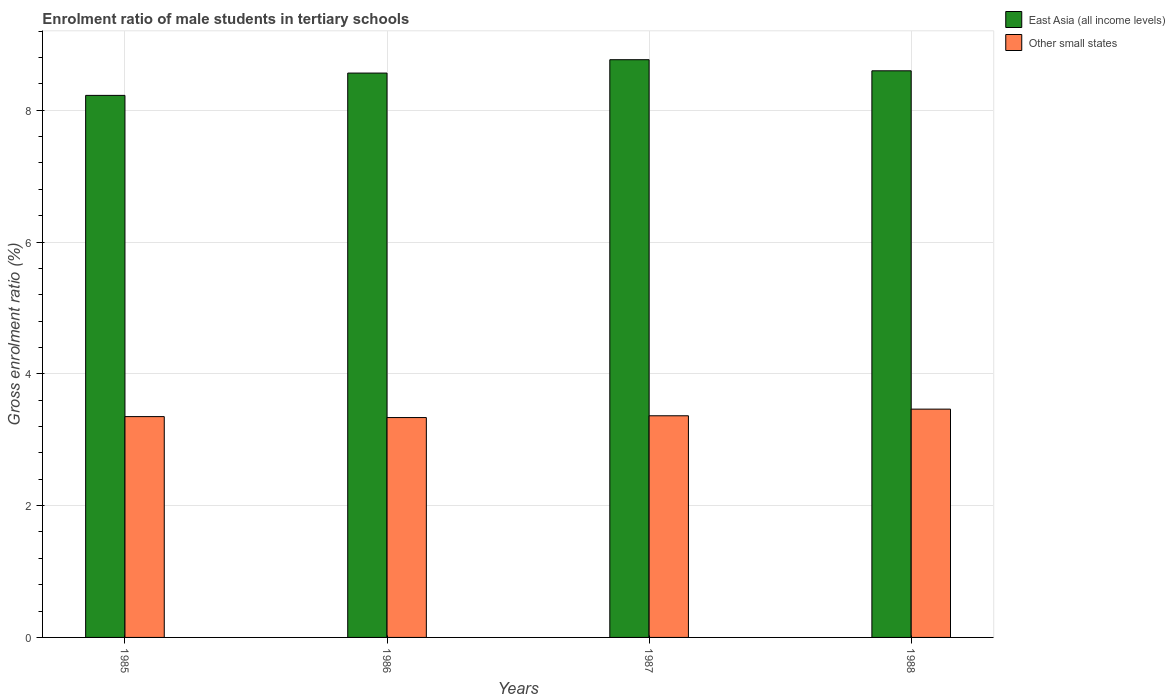How many different coloured bars are there?
Give a very brief answer. 2. How many bars are there on the 3rd tick from the right?
Keep it short and to the point. 2. What is the label of the 1st group of bars from the left?
Provide a short and direct response. 1985. In how many cases, is the number of bars for a given year not equal to the number of legend labels?
Ensure brevity in your answer.  0. What is the enrolment ratio of male students in tertiary schools in Other small states in 1987?
Your answer should be compact. 3.36. Across all years, what is the maximum enrolment ratio of male students in tertiary schools in East Asia (all income levels)?
Ensure brevity in your answer.  8.77. Across all years, what is the minimum enrolment ratio of male students in tertiary schools in East Asia (all income levels)?
Make the answer very short. 8.23. In which year was the enrolment ratio of male students in tertiary schools in East Asia (all income levels) minimum?
Provide a short and direct response. 1985. What is the total enrolment ratio of male students in tertiary schools in Other small states in the graph?
Make the answer very short. 13.52. What is the difference between the enrolment ratio of male students in tertiary schools in East Asia (all income levels) in 1986 and that in 1987?
Provide a short and direct response. -0.2. What is the difference between the enrolment ratio of male students in tertiary schools in East Asia (all income levels) in 1986 and the enrolment ratio of male students in tertiary schools in Other small states in 1985?
Your answer should be compact. 5.21. What is the average enrolment ratio of male students in tertiary schools in East Asia (all income levels) per year?
Your answer should be very brief. 8.54. In the year 1986, what is the difference between the enrolment ratio of male students in tertiary schools in Other small states and enrolment ratio of male students in tertiary schools in East Asia (all income levels)?
Your answer should be compact. -5.23. In how many years, is the enrolment ratio of male students in tertiary schools in Other small states greater than 3.2 %?
Make the answer very short. 4. What is the ratio of the enrolment ratio of male students in tertiary schools in Other small states in 1985 to that in 1988?
Offer a very short reply. 0.97. Is the enrolment ratio of male students in tertiary schools in East Asia (all income levels) in 1987 less than that in 1988?
Keep it short and to the point. No. What is the difference between the highest and the second highest enrolment ratio of male students in tertiary schools in East Asia (all income levels)?
Your response must be concise. 0.17. What is the difference between the highest and the lowest enrolment ratio of male students in tertiary schools in Other small states?
Provide a short and direct response. 0.13. In how many years, is the enrolment ratio of male students in tertiary schools in Other small states greater than the average enrolment ratio of male students in tertiary schools in Other small states taken over all years?
Keep it short and to the point. 1. Is the sum of the enrolment ratio of male students in tertiary schools in East Asia (all income levels) in 1986 and 1988 greater than the maximum enrolment ratio of male students in tertiary schools in Other small states across all years?
Make the answer very short. Yes. What does the 1st bar from the left in 1988 represents?
Ensure brevity in your answer.  East Asia (all income levels). What does the 2nd bar from the right in 1985 represents?
Keep it short and to the point. East Asia (all income levels). How many bars are there?
Your response must be concise. 8. Are all the bars in the graph horizontal?
Ensure brevity in your answer.  No. What is the difference between two consecutive major ticks on the Y-axis?
Provide a short and direct response. 2. Where does the legend appear in the graph?
Offer a terse response. Top right. How many legend labels are there?
Make the answer very short. 2. How are the legend labels stacked?
Offer a very short reply. Vertical. What is the title of the graph?
Offer a terse response. Enrolment ratio of male students in tertiary schools. Does "Fiji" appear as one of the legend labels in the graph?
Provide a succinct answer. No. What is the label or title of the X-axis?
Your answer should be very brief. Years. What is the Gross enrolment ratio (%) of East Asia (all income levels) in 1985?
Ensure brevity in your answer.  8.23. What is the Gross enrolment ratio (%) of Other small states in 1985?
Ensure brevity in your answer.  3.35. What is the Gross enrolment ratio (%) in East Asia (all income levels) in 1986?
Keep it short and to the point. 8.56. What is the Gross enrolment ratio (%) in Other small states in 1986?
Ensure brevity in your answer.  3.34. What is the Gross enrolment ratio (%) in East Asia (all income levels) in 1987?
Offer a terse response. 8.77. What is the Gross enrolment ratio (%) of Other small states in 1987?
Give a very brief answer. 3.36. What is the Gross enrolment ratio (%) of East Asia (all income levels) in 1988?
Offer a very short reply. 8.6. What is the Gross enrolment ratio (%) of Other small states in 1988?
Make the answer very short. 3.46. Across all years, what is the maximum Gross enrolment ratio (%) in East Asia (all income levels)?
Provide a succinct answer. 8.77. Across all years, what is the maximum Gross enrolment ratio (%) in Other small states?
Your response must be concise. 3.46. Across all years, what is the minimum Gross enrolment ratio (%) in East Asia (all income levels)?
Make the answer very short. 8.23. Across all years, what is the minimum Gross enrolment ratio (%) of Other small states?
Give a very brief answer. 3.34. What is the total Gross enrolment ratio (%) in East Asia (all income levels) in the graph?
Your response must be concise. 34.15. What is the total Gross enrolment ratio (%) of Other small states in the graph?
Provide a succinct answer. 13.52. What is the difference between the Gross enrolment ratio (%) of East Asia (all income levels) in 1985 and that in 1986?
Provide a succinct answer. -0.34. What is the difference between the Gross enrolment ratio (%) of Other small states in 1985 and that in 1986?
Give a very brief answer. 0.01. What is the difference between the Gross enrolment ratio (%) of East Asia (all income levels) in 1985 and that in 1987?
Provide a short and direct response. -0.54. What is the difference between the Gross enrolment ratio (%) in Other small states in 1985 and that in 1987?
Keep it short and to the point. -0.01. What is the difference between the Gross enrolment ratio (%) in East Asia (all income levels) in 1985 and that in 1988?
Provide a short and direct response. -0.37. What is the difference between the Gross enrolment ratio (%) of Other small states in 1985 and that in 1988?
Ensure brevity in your answer.  -0.11. What is the difference between the Gross enrolment ratio (%) in East Asia (all income levels) in 1986 and that in 1987?
Provide a succinct answer. -0.2. What is the difference between the Gross enrolment ratio (%) in Other small states in 1986 and that in 1987?
Provide a short and direct response. -0.03. What is the difference between the Gross enrolment ratio (%) in East Asia (all income levels) in 1986 and that in 1988?
Your answer should be very brief. -0.03. What is the difference between the Gross enrolment ratio (%) in Other small states in 1986 and that in 1988?
Offer a terse response. -0.13. What is the difference between the Gross enrolment ratio (%) in East Asia (all income levels) in 1987 and that in 1988?
Your answer should be compact. 0.17. What is the difference between the Gross enrolment ratio (%) in Other small states in 1987 and that in 1988?
Keep it short and to the point. -0.1. What is the difference between the Gross enrolment ratio (%) in East Asia (all income levels) in 1985 and the Gross enrolment ratio (%) in Other small states in 1986?
Offer a terse response. 4.89. What is the difference between the Gross enrolment ratio (%) of East Asia (all income levels) in 1985 and the Gross enrolment ratio (%) of Other small states in 1987?
Your response must be concise. 4.86. What is the difference between the Gross enrolment ratio (%) in East Asia (all income levels) in 1985 and the Gross enrolment ratio (%) in Other small states in 1988?
Offer a terse response. 4.76. What is the difference between the Gross enrolment ratio (%) of East Asia (all income levels) in 1986 and the Gross enrolment ratio (%) of Other small states in 1987?
Keep it short and to the point. 5.2. What is the difference between the Gross enrolment ratio (%) of East Asia (all income levels) in 1986 and the Gross enrolment ratio (%) of Other small states in 1988?
Give a very brief answer. 5.1. What is the difference between the Gross enrolment ratio (%) in East Asia (all income levels) in 1987 and the Gross enrolment ratio (%) in Other small states in 1988?
Provide a succinct answer. 5.3. What is the average Gross enrolment ratio (%) of East Asia (all income levels) per year?
Offer a terse response. 8.54. What is the average Gross enrolment ratio (%) of Other small states per year?
Give a very brief answer. 3.38. In the year 1985, what is the difference between the Gross enrolment ratio (%) of East Asia (all income levels) and Gross enrolment ratio (%) of Other small states?
Your answer should be very brief. 4.87. In the year 1986, what is the difference between the Gross enrolment ratio (%) of East Asia (all income levels) and Gross enrolment ratio (%) of Other small states?
Your response must be concise. 5.23. In the year 1987, what is the difference between the Gross enrolment ratio (%) in East Asia (all income levels) and Gross enrolment ratio (%) in Other small states?
Offer a terse response. 5.4. In the year 1988, what is the difference between the Gross enrolment ratio (%) of East Asia (all income levels) and Gross enrolment ratio (%) of Other small states?
Provide a short and direct response. 5.13. What is the ratio of the Gross enrolment ratio (%) of East Asia (all income levels) in 1985 to that in 1986?
Your answer should be compact. 0.96. What is the ratio of the Gross enrolment ratio (%) of East Asia (all income levels) in 1985 to that in 1987?
Give a very brief answer. 0.94. What is the ratio of the Gross enrolment ratio (%) in East Asia (all income levels) in 1985 to that in 1988?
Your answer should be compact. 0.96. What is the ratio of the Gross enrolment ratio (%) in Other small states in 1985 to that in 1988?
Provide a short and direct response. 0.97. What is the ratio of the Gross enrolment ratio (%) of East Asia (all income levels) in 1986 to that in 1987?
Make the answer very short. 0.98. What is the ratio of the Gross enrolment ratio (%) of Other small states in 1986 to that in 1987?
Your answer should be compact. 0.99. What is the ratio of the Gross enrolment ratio (%) in Other small states in 1986 to that in 1988?
Offer a very short reply. 0.96. What is the ratio of the Gross enrolment ratio (%) of East Asia (all income levels) in 1987 to that in 1988?
Give a very brief answer. 1.02. What is the ratio of the Gross enrolment ratio (%) of Other small states in 1987 to that in 1988?
Offer a very short reply. 0.97. What is the difference between the highest and the second highest Gross enrolment ratio (%) in East Asia (all income levels)?
Offer a very short reply. 0.17. What is the difference between the highest and the second highest Gross enrolment ratio (%) of Other small states?
Keep it short and to the point. 0.1. What is the difference between the highest and the lowest Gross enrolment ratio (%) in East Asia (all income levels)?
Ensure brevity in your answer.  0.54. What is the difference between the highest and the lowest Gross enrolment ratio (%) of Other small states?
Make the answer very short. 0.13. 